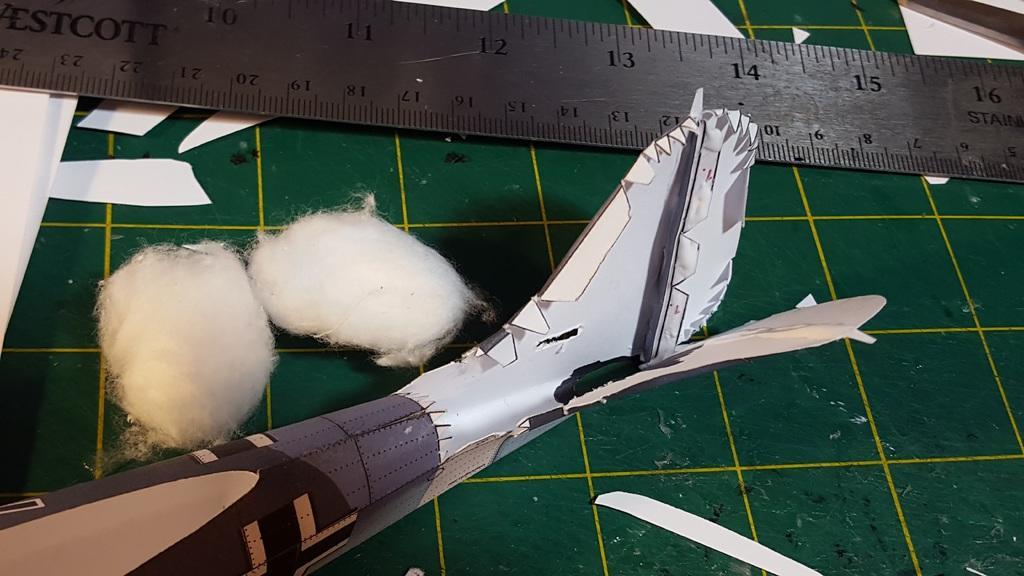How would you summarize this image in a sentence or two? In this image we can see scale, cotton balls and an object on a platform. 